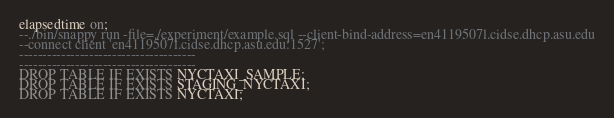<code> <loc_0><loc_0><loc_500><loc_500><_SQL_>elapsedtime on;
--./bin/snappy run -file=./experiment/example.sql --client-bind-address=en4119507l.cidse.dhcp.asu.edu
--connect client 'en4119507l.cidse.dhcp.asu.edu:1527';
--------------------------------------
--------------------------------------
DROP TABLE IF EXISTS NYCTAXI_SAMPLE;
DROP TABLE IF EXISTS STAGING_NYCTAXI;
DROP TABLE IF EXISTS NYCTAXI;</code> 